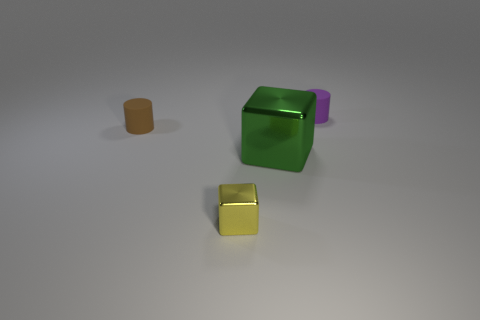What number of blue metallic cylinders are the same size as the yellow cube?
Offer a terse response. 0. Is the small cylinder that is in front of the purple cylinder made of the same material as the cube that is to the right of the yellow thing?
Give a very brief answer. No. Are there any other things that have the same shape as the small brown thing?
Ensure brevity in your answer.  Yes. What is the color of the tiny cube?
Make the answer very short. Yellow. What number of other things have the same shape as the yellow thing?
Give a very brief answer. 1. What is the color of the other matte object that is the same size as the brown thing?
Your answer should be compact. Purple. Are there any tiny gray shiny objects?
Keep it short and to the point. No. The small object that is in front of the large shiny block has what shape?
Your answer should be compact. Cube. How many rubber cylinders are both left of the small shiny block and to the right of the brown matte cylinder?
Provide a short and direct response. 0. Is there a small gray ball made of the same material as the tiny yellow object?
Provide a succinct answer. No. 